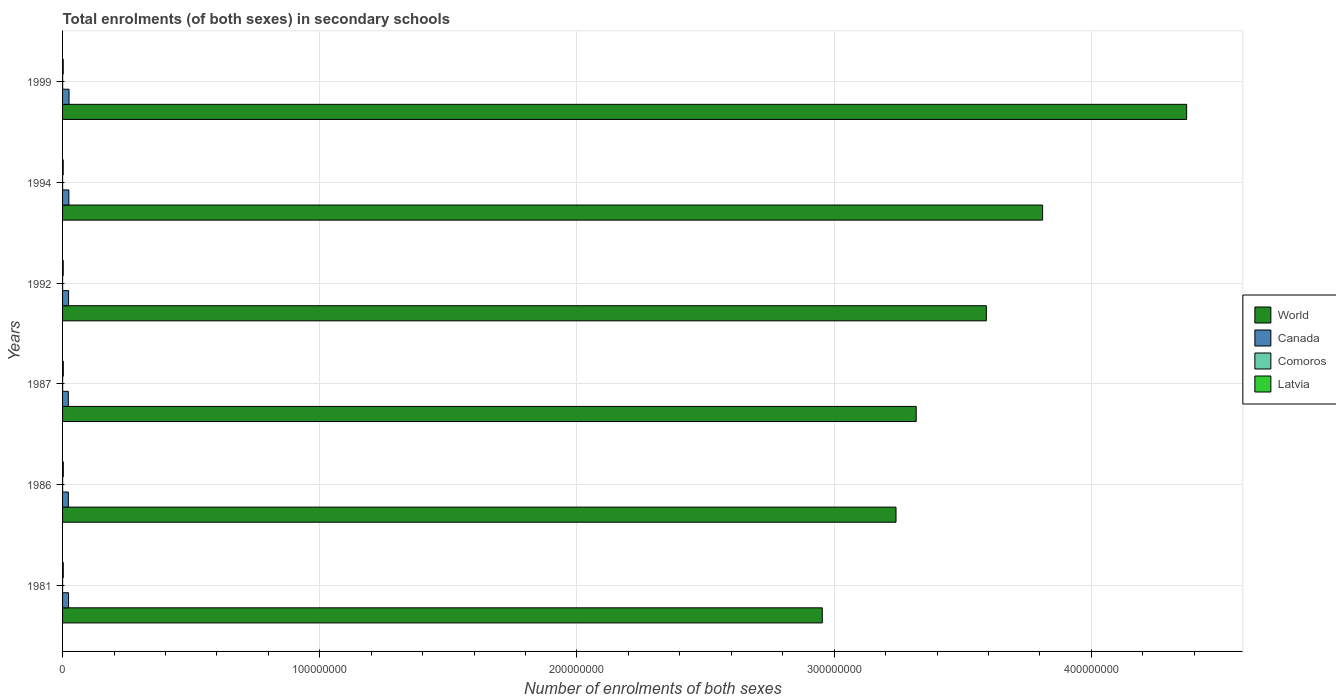How many different coloured bars are there?
Give a very brief answer. 4. Are the number of bars per tick equal to the number of legend labels?
Give a very brief answer. Yes. Are the number of bars on each tick of the Y-axis equal?
Your answer should be compact. Yes. How many bars are there on the 4th tick from the top?
Ensure brevity in your answer.  4. In how many cases, is the number of bars for a given year not equal to the number of legend labels?
Offer a terse response. 0. What is the number of enrolments in secondary schools in Comoros in 1981?
Give a very brief answer. 1.38e+04. Across all years, what is the maximum number of enrolments in secondary schools in Comoros?
Provide a succinct answer. 2.87e+04. Across all years, what is the minimum number of enrolments in secondary schools in World?
Offer a terse response. 2.95e+08. In which year was the number of enrolments in secondary schools in Canada maximum?
Give a very brief answer. 1999. In which year was the number of enrolments in secondary schools in Latvia minimum?
Provide a succinct answer. 1994. What is the total number of enrolments in secondary schools in Latvia in the graph?
Provide a succinct answer. 1.61e+06. What is the difference between the number of enrolments in secondary schools in Comoros in 1981 and that in 1992?
Keep it short and to the point. -2080. What is the difference between the number of enrolments in secondary schools in Canada in 1992 and the number of enrolments in secondary schools in World in 1994?
Provide a short and direct response. -3.79e+08. What is the average number of enrolments in secondary schools in World per year?
Make the answer very short. 3.55e+08. In the year 1987, what is the difference between the number of enrolments in secondary schools in World and number of enrolments in secondary schools in Comoros?
Keep it short and to the point. 3.32e+08. What is the ratio of the number of enrolments in secondary schools in Comoros in 1986 to that in 1992?
Your answer should be very brief. 1.33. Is the number of enrolments in secondary schools in World in 1986 less than that in 1994?
Offer a very short reply. Yes. Is the difference between the number of enrolments in secondary schools in World in 1987 and 1992 greater than the difference between the number of enrolments in secondary schools in Comoros in 1987 and 1992?
Offer a terse response. No. What is the difference between the highest and the second highest number of enrolments in secondary schools in Comoros?
Provide a succinct answer. 7550. What is the difference between the highest and the lowest number of enrolments in secondary schools in World?
Offer a very short reply. 1.42e+08. In how many years, is the number of enrolments in secondary schools in Canada greater than the average number of enrolments in secondary schools in Canada taken over all years?
Keep it short and to the point. 2. Is the sum of the number of enrolments in secondary schools in World in 1994 and 1999 greater than the maximum number of enrolments in secondary schools in Comoros across all years?
Offer a very short reply. Yes. Is it the case that in every year, the sum of the number of enrolments in secondary schools in Canada and number of enrolments in secondary schools in Latvia is greater than the number of enrolments in secondary schools in World?
Ensure brevity in your answer.  No. How many bars are there?
Offer a very short reply. 24. How many years are there in the graph?
Offer a very short reply. 6. What is the difference between two consecutive major ticks on the X-axis?
Provide a succinct answer. 1.00e+08. Does the graph contain any zero values?
Ensure brevity in your answer.  No. Does the graph contain grids?
Provide a succinct answer. Yes. How many legend labels are there?
Provide a succinct answer. 4. What is the title of the graph?
Your answer should be very brief. Total enrolments (of both sexes) in secondary schools. Does "Czech Republic" appear as one of the legend labels in the graph?
Offer a very short reply. No. What is the label or title of the X-axis?
Provide a succinct answer. Number of enrolments of both sexes. What is the Number of enrolments of both sexes in World in 1981?
Your response must be concise. 2.95e+08. What is the Number of enrolments of both sexes of Canada in 1981?
Provide a short and direct response. 2.32e+06. What is the Number of enrolments of both sexes of Comoros in 1981?
Offer a very short reply. 1.38e+04. What is the Number of enrolments of both sexes of Latvia in 1981?
Keep it short and to the point. 2.79e+05. What is the Number of enrolments of both sexes of World in 1986?
Offer a very short reply. 3.24e+08. What is the Number of enrolments of both sexes of Canada in 1986?
Give a very brief answer. 2.25e+06. What is the Number of enrolments of both sexes of Comoros in 1986?
Keep it short and to the point. 2.11e+04. What is the Number of enrolments of both sexes of Latvia in 1986?
Make the answer very short. 2.88e+05. What is the Number of enrolments of both sexes of World in 1987?
Your answer should be very brief. 3.32e+08. What is the Number of enrolments of both sexes in Canada in 1987?
Give a very brief answer. 2.24e+06. What is the Number of enrolments of both sexes in Comoros in 1987?
Provide a succinct answer. 2.12e+04. What is the Number of enrolments of both sexes in Latvia in 1987?
Your answer should be compact. 2.89e+05. What is the Number of enrolments of both sexes of World in 1992?
Provide a succinct answer. 3.59e+08. What is the Number of enrolments of both sexes of Canada in 1992?
Provide a short and direct response. 2.34e+06. What is the Number of enrolments of both sexes of Comoros in 1992?
Offer a terse response. 1.59e+04. What is the Number of enrolments of both sexes in Latvia in 1992?
Keep it short and to the point. 2.54e+05. What is the Number of enrolments of both sexes of World in 1994?
Provide a short and direct response. 3.81e+08. What is the Number of enrolments of both sexes of Canada in 1994?
Your answer should be compact. 2.46e+06. What is the Number of enrolments of both sexes in Comoros in 1994?
Ensure brevity in your answer.  1.76e+04. What is the Number of enrolments of both sexes of Latvia in 1994?
Your response must be concise. 2.45e+05. What is the Number of enrolments of both sexes of World in 1999?
Make the answer very short. 4.37e+08. What is the Number of enrolments of both sexes of Canada in 1999?
Provide a short and direct response. 2.51e+06. What is the Number of enrolments of both sexes of Comoros in 1999?
Make the answer very short. 2.87e+04. What is the Number of enrolments of both sexes in Latvia in 1999?
Offer a very short reply. 2.55e+05. Across all years, what is the maximum Number of enrolments of both sexes in World?
Give a very brief answer. 4.37e+08. Across all years, what is the maximum Number of enrolments of both sexes of Canada?
Offer a very short reply. 2.51e+06. Across all years, what is the maximum Number of enrolments of both sexes of Comoros?
Keep it short and to the point. 2.87e+04. Across all years, what is the maximum Number of enrolments of both sexes in Latvia?
Provide a short and direct response. 2.89e+05. Across all years, what is the minimum Number of enrolments of both sexes in World?
Give a very brief answer. 2.95e+08. Across all years, what is the minimum Number of enrolments of both sexes in Canada?
Provide a succinct answer. 2.24e+06. Across all years, what is the minimum Number of enrolments of both sexes of Comoros?
Your answer should be compact. 1.38e+04. Across all years, what is the minimum Number of enrolments of both sexes of Latvia?
Your response must be concise. 2.45e+05. What is the total Number of enrolments of both sexes in World in the graph?
Your answer should be compact. 2.13e+09. What is the total Number of enrolments of both sexes in Canada in the graph?
Make the answer very short. 1.41e+07. What is the total Number of enrolments of both sexes in Comoros in the graph?
Offer a terse response. 1.18e+05. What is the total Number of enrolments of both sexes of Latvia in the graph?
Your answer should be very brief. 1.61e+06. What is the difference between the Number of enrolments of both sexes of World in 1981 and that in 1986?
Provide a succinct answer. -2.87e+07. What is the difference between the Number of enrolments of both sexes of Canada in 1981 and that in 1986?
Offer a very short reply. 7.23e+04. What is the difference between the Number of enrolments of both sexes in Comoros in 1981 and that in 1986?
Your response must be concise. -7258. What is the difference between the Number of enrolments of both sexes of Latvia in 1981 and that in 1986?
Offer a terse response. -9137. What is the difference between the Number of enrolments of both sexes of World in 1981 and that in 1987?
Keep it short and to the point. -3.65e+07. What is the difference between the Number of enrolments of both sexes of Canada in 1981 and that in 1987?
Offer a terse response. 8.50e+04. What is the difference between the Number of enrolments of both sexes in Comoros in 1981 and that in 1987?
Your answer should be compact. -7370. What is the difference between the Number of enrolments of both sexes in Latvia in 1981 and that in 1987?
Ensure brevity in your answer.  -9582. What is the difference between the Number of enrolments of both sexes of World in 1981 and that in 1992?
Provide a short and direct response. -6.38e+07. What is the difference between the Number of enrolments of both sexes of Canada in 1981 and that in 1992?
Your response must be concise. -1.43e+04. What is the difference between the Number of enrolments of both sexes of Comoros in 1981 and that in 1992?
Provide a succinct answer. -2080. What is the difference between the Number of enrolments of both sexes of Latvia in 1981 and that in 1992?
Provide a short and direct response. 2.50e+04. What is the difference between the Number of enrolments of both sexes of World in 1981 and that in 1994?
Make the answer very short. -8.57e+07. What is the difference between the Number of enrolments of both sexes in Canada in 1981 and that in 1994?
Your answer should be compact. -1.32e+05. What is the difference between the Number of enrolments of both sexes of Comoros in 1981 and that in 1994?
Your answer should be compact. -3839. What is the difference between the Number of enrolments of both sexes in Latvia in 1981 and that in 1994?
Keep it short and to the point. 3.40e+04. What is the difference between the Number of enrolments of both sexes of World in 1981 and that in 1999?
Provide a short and direct response. -1.42e+08. What is the difference between the Number of enrolments of both sexes of Canada in 1981 and that in 1999?
Ensure brevity in your answer.  -1.88e+05. What is the difference between the Number of enrolments of both sexes of Comoros in 1981 and that in 1999?
Your response must be concise. -1.49e+04. What is the difference between the Number of enrolments of both sexes in Latvia in 1981 and that in 1999?
Give a very brief answer. 2.38e+04. What is the difference between the Number of enrolments of both sexes in World in 1986 and that in 1987?
Provide a short and direct response. -7.85e+06. What is the difference between the Number of enrolments of both sexes of Canada in 1986 and that in 1987?
Your response must be concise. 1.27e+04. What is the difference between the Number of enrolments of both sexes of Comoros in 1986 and that in 1987?
Your response must be concise. -112. What is the difference between the Number of enrolments of both sexes of Latvia in 1986 and that in 1987?
Provide a short and direct response. -445. What is the difference between the Number of enrolments of both sexes in World in 1986 and that in 1992?
Keep it short and to the point. -3.51e+07. What is the difference between the Number of enrolments of both sexes in Canada in 1986 and that in 1992?
Your answer should be very brief. -8.66e+04. What is the difference between the Number of enrolments of both sexes in Comoros in 1986 and that in 1992?
Your answer should be very brief. 5178. What is the difference between the Number of enrolments of both sexes of Latvia in 1986 and that in 1992?
Ensure brevity in your answer.  3.41e+04. What is the difference between the Number of enrolments of both sexes in World in 1986 and that in 1994?
Make the answer very short. -5.70e+07. What is the difference between the Number of enrolments of both sexes in Canada in 1986 and that in 1994?
Offer a very short reply. -2.04e+05. What is the difference between the Number of enrolments of both sexes in Comoros in 1986 and that in 1994?
Your response must be concise. 3419. What is the difference between the Number of enrolments of both sexes of Latvia in 1986 and that in 1994?
Ensure brevity in your answer.  4.32e+04. What is the difference between the Number of enrolments of both sexes of World in 1986 and that in 1999?
Your response must be concise. -1.13e+08. What is the difference between the Number of enrolments of both sexes in Canada in 1986 and that in 1999?
Make the answer very short. -2.61e+05. What is the difference between the Number of enrolments of both sexes in Comoros in 1986 and that in 1999?
Your answer should be very brief. -7662. What is the difference between the Number of enrolments of both sexes of Latvia in 1986 and that in 1999?
Give a very brief answer. 3.29e+04. What is the difference between the Number of enrolments of both sexes in World in 1987 and that in 1992?
Keep it short and to the point. -2.73e+07. What is the difference between the Number of enrolments of both sexes of Canada in 1987 and that in 1992?
Ensure brevity in your answer.  -9.93e+04. What is the difference between the Number of enrolments of both sexes of Comoros in 1987 and that in 1992?
Ensure brevity in your answer.  5290. What is the difference between the Number of enrolments of both sexes in Latvia in 1987 and that in 1992?
Ensure brevity in your answer.  3.46e+04. What is the difference between the Number of enrolments of both sexes of World in 1987 and that in 1994?
Ensure brevity in your answer.  -4.92e+07. What is the difference between the Number of enrolments of both sexes of Canada in 1987 and that in 1994?
Make the answer very short. -2.17e+05. What is the difference between the Number of enrolments of both sexes in Comoros in 1987 and that in 1994?
Ensure brevity in your answer.  3531. What is the difference between the Number of enrolments of both sexes in Latvia in 1987 and that in 1994?
Offer a terse response. 4.36e+04. What is the difference between the Number of enrolments of both sexes in World in 1987 and that in 1999?
Provide a succinct answer. -1.05e+08. What is the difference between the Number of enrolments of both sexes in Canada in 1987 and that in 1999?
Provide a short and direct response. -2.73e+05. What is the difference between the Number of enrolments of both sexes in Comoros in 1987 and that in 1999?
Give a very brief answer. -7550. What is the difference between the Number of enrolments of both sexes in Latvia in 1987 and that in 1999?
Your answer should be very brief. 3.34e+04. What is the difference between the Number of enrolments of both sexes in World in 1992 and that in 1994?
Ensure brevity in your answer.  -2.19e+07. What is the difference between the Number of enrolments of both sexes of Canada in 1992 and that in 1994?
Keep it short and to the point. -1.18e+05. What is the difference between the Number of enrolments of both sexes in Comoros in 1992 and that in 1994?
Offer a terse response. -1759. What is the difference between the Number of enrolments of both sexes of Latvia in 1992 and that in 1994?
Keep it short and to the point. 9066. What is the difference between the Number of enrolments of both sexes of World in 1992 and that in 1999?
Give a very brief answer. -7.79e+07. What is the difference between the Number of enrolments of both sexes of Canada in 1992 and that in 1999?
Make the answer very short. -1.74e+05. What is the difference between the Number of enrolments of both sexes of Comoros in 1992 and that in 1999?
Provide a short and direct response. -1.28e+04. What is the difference between the Number of enrolments of both sexes in Latvia in 1992 and that in 1999?
Provide a succinct answer. -1185. What is the difference between the Number of enrolments of both sexes of World in 1994 and that in 1999?
Your response must be concise. -5.60e+07. What is the difference between the Number of enrolments of both sexes of Canada in 1994 and that in 1999?
Your response must be concise. -5.61e+04. What is the difference between the Number of enrolments of both sexes of Comoros in 1994 and that in 1999?
Give a very brief answer. -1.11e+04. What is the difference between the Number of enrolments of both sexes in Latvia in 1994 and that in 1999?
Your answer should be compact. -1.03e+04. What is the difference between the Number of enrolments of both sexes of World in 1981 and the Number of enrolments of both sexes of Canada in 1986?
Provide a succinct answer. 2.93e+08. What is the difference between the Number of enrolments of both sexes of World in 1981 and the Number of enrolments of both sexes of Comoros in 1986?
Offer a very short reply. 2.95e+08. What is the difference between the Number of enrolments of both sexes in World in 1981 and the Number of enrolments of both sexes in Latvia in 1986?
Provide a succinct answer. 2.95e+08. What is the difference between the Number of enrolments of both sexes in Canada in 1981 and the Number of enrolments of both sexes in Comoros in 1986?
Offer a terse response. 2.30e+06. What is the difference between the Number of enrolments of both sexes of Canada in 1981 and the Number of enrolments of both sexes of Latvia in 1986?
Your answer should be very brief. 2.03e+06. What is the difference between the Number of enrolments of both sexes in Comoros in 1981 and the Number of enrolments of both sexes in Latvia in 1986?
Make the answer very short. -2.75e+05. What is the difference between the Number of enrolments of both sexes in World in 1981 and the Number of enrolments of both sexes in Canada in 1987?
Keep it short and to the point. 2.93e+08. What is the difference between the Number of enrolments of both sexes of World in 1981 and the Number of enrolments of both sexes of Comoros in 1987?
Offer a very short reply. 2.95e+08. What is the difference between the Number of enrolments of both sexes in World in 1981 and the Number of enrolments of both sexes in Latvia in 1987?
Ensure brevity in your answer.  2.95e+08. What is the difference between the Number of enrolments of both sexes of Canada in 1981 and the Number of enrolments of both sexes of Comoros in 1987?
Your answer should be compact. 2.30e+06. What is the difference between the Number of enrolments of both sexes in Canada in 1981 and the Number of enrolments of both sexes in Latvia in 1987?
Offer a terse response. 2.03e+06. What is the difference between the Number of enrolments of both sexes of Comoros in 1981 and the Number of enrolments of both sexes of Latvia in 1987?
Provide a short and direct response. -2.75e+05. What is the difference between the Number of enrolments of both sexes of World in 1981 and the Number of enrolments of both sexes of Canada in 1992?
Your answer should be compact. 2.93e+08. What is the difference between the Number of enrolments of both sexes of World in 1981 and the Number of enrolments of both sexes of Comoros in 1992?
Offer a very short reply. 2.95e+08. What is the difference between the Number of enrolments of both sexes in World in 1981 and the Number of enrolments of both sexes in Latvia in 1992?
Offer a terse response. 2.95e+08. What is the difference between the Number of enrolments of both sexes of Canada in 1981 and the Number of enrolments of both sexes of Comoros in 1992?
Offer a terse response. 2.31e+06. What is the difference between the Number of enrolments of both sexes in Canada in 1981 and the Number of enrolments of both sexes in Latvia in 1992?
Keep it short and to the point. 2.07e+06. What is the difference between the Number of enrolments of both sexes in Comoros in 1981 and the Number of enrolments of both sexes in Latvia in 1992?
Offer a very short reply. -2.40e+05. What is the difference between the Number of enrolments of both sexes in World in 1981 and the Number of enrolments of both sexes in Canada in 1994?
Provide a succinct answer. 2.93e+08. What is the difference between the Number of enrolments of both sexes in World in 1981 and the Number of enrolments of both sexes in Comoros in 1994?
Make the answer very short. 2.95e+08. What is the difference between the Number of enrolments of both sexes of World in 1981 and the Number of enrolments of both sexes of Latvia in 1994?
Keep it short and to the point. 2.95e+08. What is the difference between the Number of enrolments of both sexes of Canada in 1981 and the Number of enrolments of both sexes of Comoros in 1994?
Your answer should be compact. 2.31e+06. What is the difference between the Number of enrolments of both sexes of Canada in 1981 and the Number of enrolments of both sexes of Latvia in 1994?
Your response must be concise. 2.08e+06. What is the difference between the Number of enrolments of both sexes in Comoros in 1981 and the Number of enrolments of both sexes in Latvia in 1994?
Make the answer very short. -2.31e+05. What is the difference between the Number of enrolments of both sexes in World in 1981 and the Number of enrolments of both sexes in Canada in 1999?
Offer a very short reply. 2.93e+08. What is the difference between the Number of enrolments of both sexes of World in 1981 and the Number of enrolments of both sexes of Comoros in 1999?
Offer a terse response. 2.95e+08. What is the difference between the Number of enrolments of both sexes in World in 1981 and the Number of enrolments of both sexes in Latvia in 1999?
Your response must be concise. 2.95e+08. What is the difference between the Number of enrolments of both sexes of Canada in 1981 and the Number of enrolments of both sexes of Comoros in 1999?
Your response must be concise. 2.29e+06. What is the difference between the Number of enrolments of both sexes of Canada in 1981 and the Number of enrolments of both sexes of Latvia in 1999?
Ensure brevity in your answer.  2.07e+06. What is the difference between the Number of enrolments of both sexes of Comoros in 1981 and the Number of enrolments of both sexes of Latvia in 1999?
Make the answer very short. -2.42e+05. What is the difference between the Number of enrolments of both sexes of World in 1986 and the Number of enrolments of both sexes of Canada in 1987?
Provide a short and direct response. 3.22e+08. What is the difference between the Number of enrolments of both sexes in World in 1986 and the Number of enrolments of both sexes in Comoros in 1987?
Give a very brief answer. 3.24e+08. What is the difference between the Number of enrolments of both sexes of World in 1986 and the Number of enrolments of both sexes of Latvia in 1987?
Offer a terse response. 3.24e+08. What is the difference between the Number of enrolments of both sexes of Canada in 1986 and the Number of enrolments of both sexes of Comoros in 1987?
Ensure brevity in your answer.  2.23e+06. What is the difference between the Number of enrolments of both sexes in Canada in 1986 and the Number of enrolments of both sexes in Latvia in 1987?
Provide a succinct answer. 1.96e+06. What is the difference between the Number of enrolments of both sexes of Comoros in 1986 and the Number of enrolments of both sexes of Latvia in 1987?
Ensure brevity in your answer.  -2.68e+05. What is the difference between the Number of enrolments of both sexes in World in 1986 and the Number of enrolments of both sexes in Canada in 1992?
Offer a very short reply. 3.22e+08. What is the difference between the Number of enrolments of both sexes of World in 1986 and the Number of enrolments of both sexes of Comoros in 1992?
Keep it short and to the point. 3.24e+08. What is the difference between the Number of enrolments of both sexes in World in 1986 and the Number of enrolments of both sexes in Latvia in 1992?
Your answer should be very brief. 3.24e+08. What is the difference between the Number of enrolments of both sexes in Canada in 1986 and the Number of enrolments of both sexes in Comoros in 1992?
Your response must be concise. 2.24e+06. What is the difference between the Number of enrolments of both sexes in Canada in 1986 and the Number of enrolments of both sexes in Latvia in 1992?
Ensure brevity in your answer.  2.00e+06. What is the difference between the Number of enrolments of both sexes of Comoros in 1986 and the Number of enrolments of both sexes of Latvia in 1992?
Offer a terse response. -2.33e+05. What is the difference between the Number of enrolments of both sexes of World in 1986 and the Number of enrolments of both sexes of Canada in 1994?
Your answer should be compact. 3.22e+08. What is the difference between the Number of enrolments of both sexes in World in 1986 and the Number of enrolments of both sexes in Comoros in 1994?
Provide a succinct answer. 3.24e+08. What is the difference between the Number of enrolments of both sexes in World in 1986 and the Number of enrolments of both sexes in Latvia in 1994?
Your response must be concise. 3.24e+08. What is the difference between the Number of enrolments of both sexes of Canada in 1986 and the Number of enrolments of both sexes of Comoros in 1994?
Provide a short and direct response. 2.23e+06. What is the difference between the Number of enrolments of both sexes of Canada in 1986 and the Number of enrolments of both sexes of Latvia in 1994?
Make the answer very short. 2.01e+06. What is the difference between the Number of enrolments of both sexes of Comoros in 1986 and the Number of enrolments of both sexes of Latvia in 1994?
Ensure brevity in your answer.  -2.24e+05. What is the difference between the Number of enrolments of both sexes in World in 1986 and the Number of enrolments of both sexes in Canada in 1999?
Make the answer very short. 3.22e+08. What is the difference between the Number of enrolments of both sexes in World in 1986 and the Number of enrolments of both sexes in Comoros in 1999?
Your answer should be very brief. 3.24e+08. What is the difference between the Number of enrolments of both sexes in World in 1986 and the Number of enrolments of both sexes in Latvia in 1999?
Offer a terse response. 3.24e+08. What is the difference between the Number of enrolments of both sexes of Canada in 1986 and the Number of enrolments of both sexes of Comoros in 1999?
Offer a very short reply. 2.22e+06. What is the difference between the Number of enrolments of both sexes in Canada in 1986 and the Number of enrolments of both sexes in Latvia in 1999?
Your answer should be very brief. 2.00e+06. What is the difference between the Number of enrolments of both sexes of Comoros in 1986 and the Number of enrolments of both sexes of Latvia in 1999?
Your answer should be compact. -2.34e+05. What is the difference between the Number of enrolments of both sexes of World in 1987 and the Number of enrolments of both sexes of Canada in 1992?
Provide a short and direct response. 3.30e+08. What is the difference between the Number of enrolments of both sexes in World in 1987 and the Number of enrolments of both sexes in Comoros in 1992?
Your answer should be very brief. 3.32e+08. What is the difference between the Number of enrolments of both sexes of World in 1987 and the Number of enrolments of both sexes of Latvia in 1992?
Provide a short and direct response. 3.32e+08. What is the difference between the Number of enrolments of both sexes in Canada in 1987 and the Number of enrolments of both sexes in Comoros in 1992?
Make the answer very short. 2.22e+06. What is the difference between the Number of enrolments of both sexes in Canada in 1987 and the Number of enrolments of both sexes in Latvia in 1992?
Offer a very short reply. 1.98e+06. What is the difference between the Number of enrolments of both sexes of Comoros in 1987 and the Number of enrolments of both sexes of Latvia in 1992?
Provide a short and direct response. -2.33e+05. What is the difference between the Number of enrolments of both sexes in World in 1987 and the Number of enrolments of both sexes in Canada in 1994?
Your answer should be compact. 3.29e+08. What is the difference between the Number of enrolments of both sexes in World in 1987 and the Number of enrolments of both sexes in Comoros in 1994?
Offer a very short reply. 3.32e+08. What is the difference between the Number of enrolments of both sexes of World in 1987 and the Number of enrolments of both sexes of Latvia in 1994?
Give a very brief answer. 3.32e+08. What is the difference between the Number of enrolments of both sexes of Canada in 1987 and the Number of enrolments of both sexes of Comoros in 1994?
Your response must be concise. 2.22e+06. What is the difference between the Number of enrolments of both sexes in Canada in 1987 and the Number of enrolments of both sexes in Latvia in 1994?
Provide a succinct answer. 1.99e+06. What is the difference between the Number of enrolments of both sexes of Comoros in 1987 and the Number of enrolments of both sexes of Latvia in 1994?
Make the answer very short. -2.24e+05. What is the difference between the Number of enrolments of both sexes of World in 1987 and the Number of enrolments of both sexes of Canada in 1999?
Provide a succinct answer. 3.29e+08. What is the difference between the Number of enrolments of both sexes of World in 1987 and the Number of enrolments of both sexes of Comoros in 1999?
Your answer should be very brief. 3.32e+08. What is the difference between the Number of enrolments of both sexes in World in 1987 and the Number of enrolments of both sexes in Latvia in 1999?
Your answer should be very brief. 3.32e+08. What is the difference between the Number of enrolments of both sexes in Canada in 1987 and the Number of enrolments of both sexes in Comoros in 1999?
Ensure brevity in your answer.  2.21e+06. What is the difference between the Number of enrolments of both sexes of Canada in 1987 and the Number of enrolments of both sexes of Latvia in 1999?
Provide a short and direct response. 1.98e+06. What is the difference between the Number of enrolments of both sexes of Comoros in 1987 and the Number of enrolments of both sexes of Latvia in 1999?
Provide a succinct answer. -2.34e+05. What is the difference between the Number of enrolments of both sexes of World in 1992 and the Number of enrolments of both sexes of Canada in 1994?
Keep it short and to the point. 3.57e+08. What is the difference between the Number of enrolments of both sexes in World in 1992 and the Number of enrolments of both sexes in Comoros in 1994?
Your answer should be compact. 3.59e+08. What is the difference between the Number of enrolments of both sexes of World in 1992 and the Number of enrolments of both sexes of Latvia in 1994?
Your response must be concise. 3.59e+08. What is the difference between the Number of enrolments of both sexes of Canada in 1992 and the Number of enrolments of both sexes of Comoros in 1994?
Your response must be concise. 2.32e+06. What is the difference between the Number of enrolments of both sexes of Canada in 1992 and the Number of enrolments of both sexes of Latvia in 1994?
Keep it short and to the point. 2.09e+06. What is the difference between the Number of enrolments of both sexes in Comoros in 1992 and the Number of enrolments of both sexes in Latvia in 1994?
Offer a terse response. -2.29e+05. What is the difference between the Number of enrolments of both sexes in World in 1992 and the Number of enrolments of both sexes in Canada in 1999?
Your answer should be compact. 3.57e+08. What is the difference between the Number of enrolments of both sexes of World in 1992 and the Number of enrolments of both sexes of Comoros in 1999?
Make the answer very short. 3.59e+08. What is the difference between the Number of enrolments of both sexes in World in 1992 and the Number of enrolments of both sexes in Latvia in 1999?
Provide a succinct answer. 3.59e+08. What is the difference between the Number of enrolments of both sexes of Canada in 1992 and the Number of enrolments of both sexes of Comoros in 1999?
Offer a very short reply. 2.31e+06. What is the difference between the Number of enrolments of both sexes in Canada in 1992 and the Number of enrolments of both sexes in Latvia in 1999?
Your response must be concise. 2.08e+06. What is the difference between the Number of enrolments of both sexes in Comoros in 1992 and the Number of enrolments of both sexes in Latvia in 1999?
Your response must be concise. -2.40e+05. What is the difference between the Number of enrolments of both sexes in World in 1994 and the Number of enrolments of both sexes in Canada in 1999?
Make the answer very short. 3.79e+08. What is the difference between the Number of enrolments of both sexes in World in 1994 and the Number of enrolments of both sexes in Comoros in 1999?
Ensure brevity in your answer.  3.81e+08. What is the difference between the Number of enrolments of both sexes of World in 1994 and the Number of enrolments of both sexes of Latvia in 1999?
Give a very brief answer. 3.81e+08. What is the difference between the Number of enrolments of both sexes of Canada in 1994 and the Number of enrolments of both sexes of Comoros in 1999?
Keep it short and to the point. 2.43e+06. What is the difference between the Number of enrolments of both sexes in Canada in 1994 and the Number of enrolments of both sexes in Latvia in 1999?
Your answer should be compact. 2.20e+06. What is the difference between the Number of enrolments of both sexes of Comoros in 1994 and the Number of enrolments of both sexes of Latvia in 1999?
Your response must be concise. -2.38e+05. What is the average Number of enrolments of both sexes of World per year?
Your answer should be compact. 3.55e+08. What is the average Number of enrolments of both sexes of Canada per year?
Offer a very short reply. 2.35e+06. What is the average Number of enrolments of both sexes in Comoros per year?
Your response must be concise. 1.97e+04. What is the average Number of enrolments of both sexes of Latvia per year?
Offer a very short reply. 2.68e+05. In the year 1981, what is the difference between the Number of enrolments of both sexes in World and Number of enrolments of both sexes in Canada?
Provide a short and direct response. 2.93e+08. In the year 1981, what is the difference between the Number of enrolments of both sexes of World and Number of enrolments of both sexes of Comoros?
Your answer should be compact. 2.95e+08. In the year 1981, what is the difference between the Number of enrolments of both sexes of World and Number of enrolments of both sexes of Latvia?
Ensure brevity in your answer.  2.95e+08. In the year 1981, what is the difference between the Number of enrolments of both sexes in Canada and Number of enrolments of both sexes in Comoros?
Your response must be concise. 2.31e+06. In the year 1981, what is the difference between the Number of enrolments of both sexes of Canada and Number of enrolments of both sexes of Latvia?
Ensure brevity in your answer.  2.04e+06. In the year 1981, what is the difference between the Number of enrolments of both sexes of Comoros and Number of enrolments of both sexes of Latvia?
Provide a short and direct response. -2.65e+05. In the year 1986, what is the difference between the Number of enrolments of both sexes in World and Number of enrolments of both sexes in Canada?
Your answer should be compact. 3.22e+08. In the year 1986, what is the difference between the Number of enrolments of both sexes in World and Number of enrolments of both sexes in Comoros?
Give a very brief answer. 3.24e+08. In the year 1986, what is the difference between the Number of enrolments of both sexes of World and Number of enrolments of both sexes of Latvia?
Offer a very short reply. 3.24e+08. In the year 1986, what is the difference between the Number of enrolments of both sexes in Canada and Number of enrolments of both sexes in Comoros?
Keep it short and to the point. 2.23e+06. In the year 1986, what is the difference between the Number of enrolments of both sexes in Canada and Number of enrolments of both sexes in Latvia?
Your response must be concise. 1.96e+06. In the year 1986, what is the difference between the Number of enrolments of both sexes in Comoros and Number of enrolments of both sexes in Latvia?
Ensure brevity in your answer.  -2.67e+05. In the year 1987, what is the difference between the Number of enrolments of both sexes of World and Number of enrolments of both sexes of Canada?
Provide a succinct answer. 3.30e+08. In the year 1987, what is the difference between the Number of enrolments of both sexes in World and Number of enrolments of both sexes in Comoros?
Ensure brevity in your answer.  3.32e+08. In the year 1987, what is the difference between the Number of enrolments of both sexes in World and Number of enrolments of both sexes in Latvia?
Your answer should be compact. 3.32e+08. In the year 1987, what is the difference between the Number of enrolments of both sexes in Canada and Number of enrolments of both sexes in Comoros?
Your answer should be very brief. 2.22e+06. In the year 1987, what is the difference between the Number of enrolments of both sexes in Canada and Number of enrolments of both sexes in Latvia?
Provide a succinct answer. 1.95e+06. In the year 1987, what is the difference between the Number of enrolments of both sexes in Comoros and Number of enrolments of both sexes in Latvia?
Your answer should be very brief. -2.68e+05. In the year 1992, what is the difference between the Number of enrolments of both sexes in World and Number of enrolments of both sexes in Canada?
Keep it short and to the point. 3.57e+08. In the year 1992, what is the difference between the Number of enrolments of both sexes of World and Number of enrolments of both sexes of Comoros?
Ensure brevity in your answer.  3.59e+08. In the year 1992, what is the difference between the Number of enrolments of both sexes of World and Number of enrolments of both sexes of Latvia?
Offer a very short reply. 3.59e+08. In the year 1992, what is the difference between the Number of enrolments of both sexes of Canada and Number of enrolments of both sexes of Comoros?
Your answer should be compact. 2.32e+06. In the year 1992, what is the difference between the Number of enrolments of both sexes in Canada and Number of enrolments of both sexes in Latvia?
Offer a very short reply. 2.08e+06. In the year 1992, what is the difference between the Number of enrolments of both sexes in Comoros and Number of enrolments of both sexes in Latvia?
Your answer should be compact. -2.38e+05. In the year 1994, what is the difference between the Number of enrolments of both sexes of World and Number of enrolments of both sexes of Canada?
Provide a succinct answer. 3.79e+08. In the year 1994, what is the difference between the Number of enrolments of both sexes of World and Number of enrolments of both sexes of Comoros?
Make the answer very short. 3.81e+08. In the year 1994, what is the difference between the Number of enrolments of both sexes of World and Number of enrolments of both sexes of Latvia?
Offer a terse response. 3.81e+08. In the year 1994, what is the difference between the Number of enrolments of both sexes in Canada and Number of enrolments of both sexes in Comoros?
Keep it short and to the point. 2.44e+06. In the year 1994, what is the difference between the Number of enrolments of both sexes of Canada and Number of enrolments of both sexes of Latvia?
Your answer should be compact. 2.21e+06. In the year 1994, what is the difference between the Number of enrolments of both sexes of Comoros and Number of enrolments of both sexes of Latvia?
Ensure brevity in your answer.  -2.27e+05. In the year 1999, what is the difference between the Number of enrolments of both sexes of World and Number of enrolments of both sexes of Canada?
Keep it short and to the point. 4.35e+08. In the year 1999, what is the difference between the Number of enrolments of both sexes in World and Number of enrolments of both sexes in Comoros?
Make the answer very short. 4.37e+08. In the year 1999, what is the difference between the Number of enrolments of both sexes in World and Number of enrolments of both sexes in Latvia?
Your answer should be compact. 4.37e+08. In the year 1999, what is the difference between the Number of enrolments of both sexes in Canada and Number of enrolments of both sexes in Comoros?
Provide a succinct answer. 2.48e+06. In the year 1999, what is the difference between the Number of enrolments of both sexes of Canada and Number of enrolments of both sexes of Latvia?
Provide a short and direct response. 2.26e+06. In the year 1999, what is the difference between the Number of enrolments of both sexes of Comoros and Number of enrolments of both sexes of Latvia?
Give a very brief answer. -2.27e+05. What is the ratio of the Number of enrolments of both sexes in World in 1981 to that in 1986?
Offer a very short reply. 0.91. What is the ratio of the Number of enrolments of both sexes in Canada in 1981 to that in 1986?
Offer a terse response. 1.03. What is the ratio of the Number of enrolments of both sexes in Comoros in 1981 to that in 1986?
Offer a terse response. 0.66. What is the ratio of the Number of enrolments of both sexes in Latvia in 1981 to that in 1986?
Offer a very short reply. 0.97. What is the ratio of the Number of enrolments of both sexes in World in 1981 to that in 1987?
Offer a very short reply. 0.89. What is the ratio of the Number of enrolments of both sexes of Canada in 1981 to that in 1987?
Ensure brevity in your answer.  1.04. What is the ratio of the Number of enrolments of both sexes in Comoros in 1981 to that in 1987?
Provide a short and direct response. 0.65. What is the ratio of the Number of enrolments of both sexes of Latvia in 1981 to that in 1987?
Provide a succinct answer. 0.97. What is the ratio of the Number of enrolments of both sexes in World in 1981 to that in 1992?
Provide a short and direct response. 0.82. What is the ratio of the Number of enrolments of both sexes of Comoros in 1981 to that in 1992?
Your response must be concise. 0.87. What is the ratio of the Number of enrolments of both sexes in Latvia in 1981 to that in 1992?
Ensure brevity in your answer.  1.1. What is the ratio of the Number of enrolments of both sexes of World in 1981 to that in 1994?
Provide a succinct answer. 0.78. What is the ratio of the Number of enrolments of both sexes of Canada in 1981 to that in 1994?
Provide a short and direct response. 0.95. What is the ratio of the Number of enrolments of both sexes of Comoros in 1981 to that in 1994?
Offer a terse response. 0.78. What is the ratio of the Number of enrolments of both sexes of Latvia in 1981 to that in 1994?
Keep it short and to the point. 1.14. What is the ratio of the Number of enrolments of both sexes in World in 1981 to that in 1999?
Make the answer very short. 0.68. What is the ratio of the Number of enrolments of both sexes in Canada in 1981 to that in 1999?
Your answer should be very brief. 0.93. What is the ratio of the Number of enrolments of both sexes in Comoros in 1981 to that in 1999?
Your answer should be very brief. 0.48. What is the ratio of the Number of enrolments of both sexes in Latvia in 1981 to that in 1999?
Provide a short and direct response. 1.09. What is the ratio of the Number of enrolments of both sexes of World in 1986 to that in 1987?
Give a very brief answer. 0.98. What is the ratio of the Number of enrolments of both sexes of Comoros in 1986 to that in 1987?
Provide a succinct answer. 0.99. What is the ratio of the Number of enrolments of both sexes in Latvia in 1986 to that in 1987?
Your answer should be very brief. 1. What is the ratio of the Number of enrolments of both sexes of World in 1986 to that in 1992?
Offer a terse response. 0.9. What is the ratio of the Number of enrolments of both sexes of Canada in 1986 to that in 1992?
Your response must be concise. 0.96. What is the ratio of the Number of enrolments of both sexes of Comoros in 1986 to that in 1992?
Your response must be concise. 1.33. What is the ratio of the Number of enrolments of both sexes of Latvia in 1986 to that in 1992?
Offer a very short reply. 1.13. What is the ratio of the Number of enrolments of both sexes of World in 1986 to that in 1994?
Give a very brief answer. 0.85. What is the ratio of the Number of enrolments of both sexes of Canada in 1986 to that in 1994?
Your response must be concise. 0.92. What is the ratio of the Number of enrolments of both sexes in Comoros in 1986 to that in 1994?
Ensure brevity in your answer.  1.19. What is the ratio of the Number of enrolments of both sexes in Latvia in 1986 to that in 1994?
Your response must be concise. 1.18. What is the ratio of the Number of enrolments of both sexes of World in 1986 to that in 1999?
Make the answer very short. 0.74. What is the ratio of the Number of enrolments of both sexes of Canada in 1986 to that in 1999?
Your answer should be compact. 0.9. What is the ratio of the Number of enrolments of both sexes of Comoros in 1986 to that in 1999?
Give a very brief answer. 0.73. What is the ratio of the Number of enrolments of both sexes of Latvia in 1986 to that in 1999?
Your answer should be very brief. 1.13. What is the ratio of the Number of enrolments of both sexes of World in 1987 to that in 1992?
Your answer should be compact. 0.92. What is the ratio of the Number of enrolments of both sexes of Canada in 1987 to that in 1992?
Offer a terse response. 0.96. What is the ratio of the Number of enrolments of both sexes of Comoros in 1987 to that in 1992?
Your answer should be compact. 1.33. What is the ratio of the Number of enrolments of both sexes in Latvia in 1987 to that in 1992?
Provide a short and direct response. 1.14. What is the ratio of the Number of enrolments of both sexes in World in 1987 to that in 1994?
Keep it short and to the point. 0.87. What is the ratio of the Number of enrolments of both sexes in Canada in 1987 to that in 1994?
Give a very brief answer. 0.91. What is the ratio of the Number of enrolments of both sexes in Comoros in 1987 to that in 1994?
Provide a short and direct response. 1.2. What is the ratio of the Number of enrolments of both sexes in Latvia in 1987 to that in 1994?
Provide a succinct answer. 1.18. What is the ratio of the Number of enrolments of both sexes in World in 1987 to that in 1999?
Ensure brevity in your answer.  0.76. What is the ratio of the Number of enrolments of both sexes in Canada in 1987 to that in 1999?
Give a very brief answer. 0.89. What is the ratio of the Number of enrolments of both sexes of Comoros in 1987 to that in 1999?
Give a very brief answer. 0.74. What is the ratio of the Number of enrolments of both sexes in Latvia in 1987 to that in 1999?
Provide a short and direct response. 1.13. What is the ratio of the Number of enrolments of both sexes in World in 1992 to that in 1994?
Provide a short and direct response. 0.94. What is the ratio of the Number of enrolments of both sexes in Canada in 1992 to that in 1994?
Offer a terse response. 0.95. What is the ratio of the Number of enrolments of both sexes in Comoros in 1992 to that in 1994?
Provide a short and direct response. 0.9. What is the ratio of the Number of enrolments of both sexes of Latvia in 1992 to that in 1994?
Your answer should be compact. 1.04. What is the ratio of the Number of enrolments of both sexes of World in 1992 to that in 1999?
Give a very brief answer. 0.82. What is the ratio of the Number of enrolments of both sexes in Canada in 1992 to that in 1999?
Provide a succinct answer. 0.93. What is the ratio of the Number of enrolments of both sexes of Comoros in 1992 to that in 1999?
Make the answer very short. 0.55. What is the ratio of the Number of enrolments of both sexes in Latvia in 1992 to that in 1999?
Make the answer very short. 1. What is the ratio of the Number of enrolments of both sexes in World in 1994 to that in 1999?
Provide a succinct answer. 0.87. What is the ratio of the Number of enrolments of both sexes in Canada in 1994 to that in 1999?
Give a very brief answer. 0.98. What is the ratio of the Number of enrolments of both sexes in Comoros in 1994 to that in 1999?
Offer a very short reply. 0.61. What is the ratio of the Number of enrolments of both sexes of Latvia in 1994 to that in 1999?
Keep it short and to the point. 0.96. What is the difference between the highest and the second highest Number of enrolments of both sexes in World?
Provide a succinct answer. 5.60e+07. What is the difference between the highest and the second highest Number of enrolments of both sexes of Canada?
Provide a short and direct response. 5.61e+04. What is the difference between the highest and the second highest Number of enrolments of both sexes of Comoros?
Make the answer very short. 7550. What is the difference between the highest and the second highest Number of enrolments of both sexes in Latvia?
Your answer should be very brief. 445. What is the difference between the highest and the lowest Number of enrolments of both sexes of World?
Offer a very short reply. 1.42e+08. What is the difference between the highest and the lowest Number of enrolments of both sexes of Canada?
Provide a short and direct response. 2.73e+05. What is the difference between the highest and the lowest Number of enrolments of both sexes in Comoros?
Provide a succinct answer. 1.49e+04. What is the difference between the highest and the lowest Number of enrolments of both sexes in Latvia?
Give a very brief answer. 4.36e+04. 